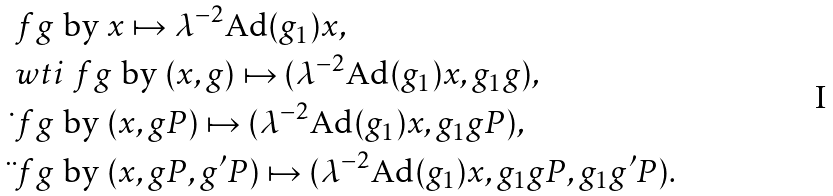Convert formula to latex. <formula><loc_0><loc_0><loc_500><loc_500>& \ f g \text { by } x \mapsto \lambda ^ { - 2 } \text {Ad} ( g _ { 1 } ) x , \\ & \ w t i \ f g \text { by } ( x , g ) \mapsto ( \lambda ^ { - 2 } \text {Ad} ( g _ { 1 } ) x , g _ { 1 } g ) , \\ & \dot { \ } f g \text { by } ( x , g P ) \mapsto ( \lambda ^ { - 2 } \text {Ad} ( g _ { 1 } ) x , g _ { 1 } g P ) , \\ & \ddot { \ } f g \text { by } ( x , g P , g ^ { \prime } P ) \mapsto ( \lambda ^ { - 2 } \text {Ad} ( g _ { 1 } ) x , g _ { 1 } g P , g _ { 1 } g ^ { \prime } P ) .</formula> 